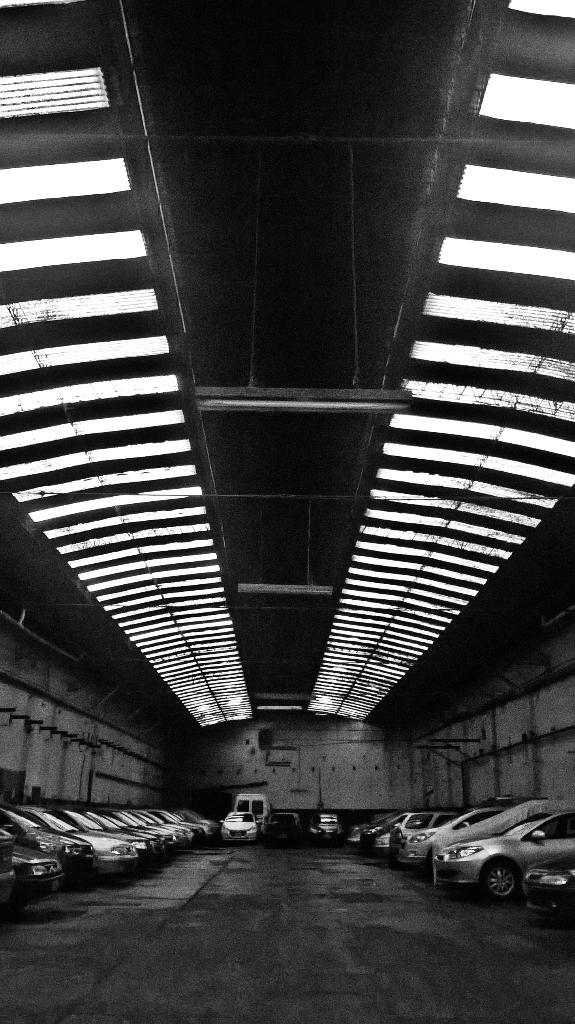What type of vehicles are at the bottom of the image? There are many cars at the bottom of the image. What part of the structure is visible in the image? The floor, wall, and roof are visible in the image. What can be seen at the top of the image? There are lights and a shed at the top of the image. Can you see a farmer kicking a bone in the image? There is no farmer or bone present in the image. What type of animal might be associated with a bone in the image? There is no animal or bone present in the image, so it's not possible to determine any associations. 